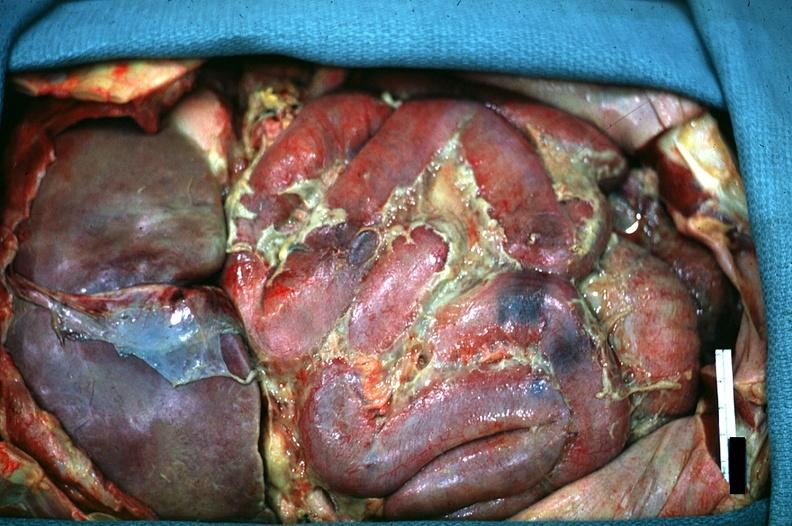s acute peritonitis present?
Answer the question using a single word or phrase. Yes 